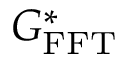Convert formula to latex. <formula><loc_0><loc_0><loc_500><loc_500>G _ { F F T } ^ { * }</formula> 